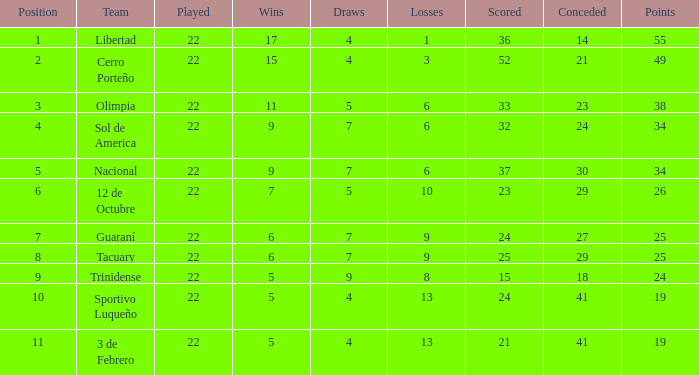What is the value scored when there were 19 points for the team 3 de Febrero? 21.0. 